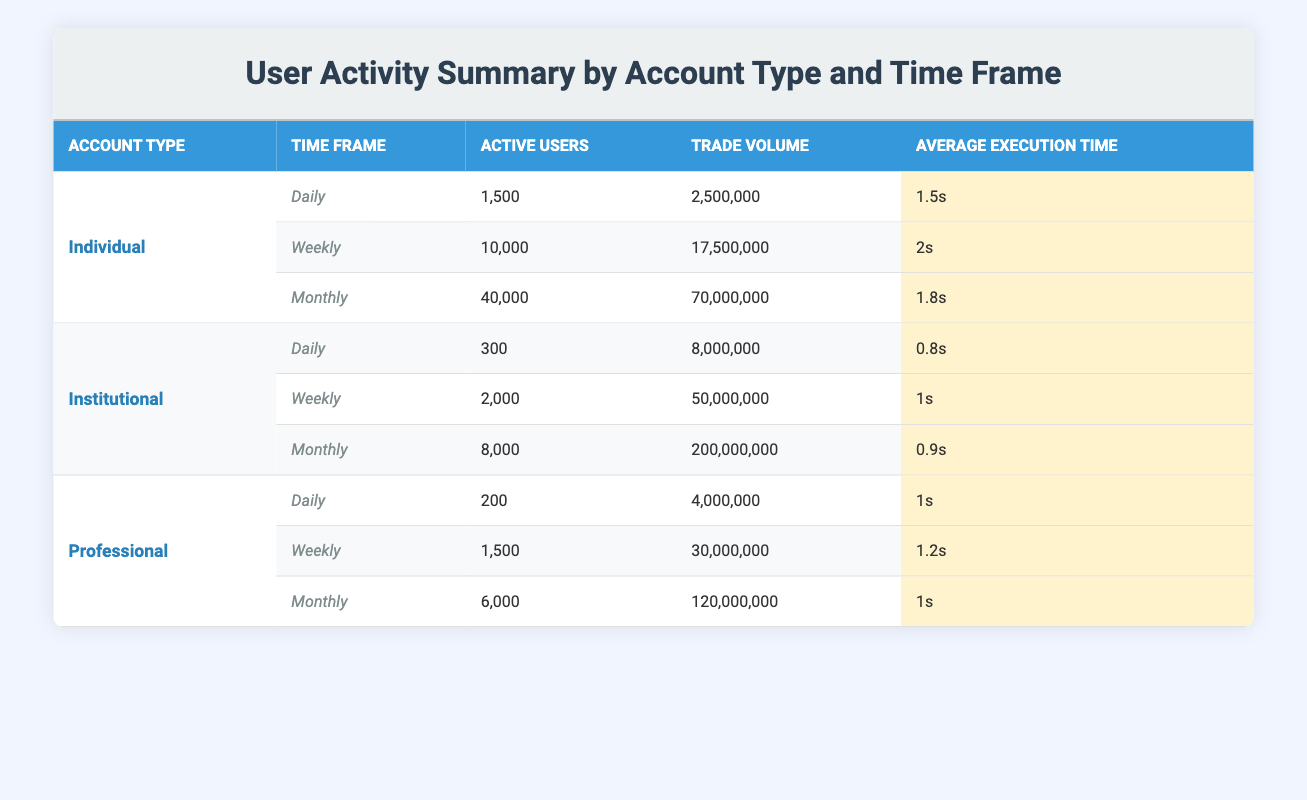What is the average execution time for Individual accounts on a daily basis? Referring to the Daily row under Individual, the Average Execution Time is displayed as 1.5s.
Answer: 1.5s How many Active Users are there for Institutional accounts during the Weekly time frame? Looking at the Weekly row for Institutional accounts, the number of Active Users is 2000.
Answer: 2000 What is the Trade Volume for Professional accounts on a Monthly basis? The Monthly row for Professional accounts shows the Trade Volume as 120,000,000.
Answer: 120,000,000 Is the Average Execution Time for Institutional accounts lower than that for Individual accounts on a Monthly basis? For Individual accounts, the Average Execution Time is 1.8s, and for Institutional accounts, it is 0.9s. Since 0.9s is less than 1.8s, the statement is true.
Answer: Yes What is the total Trade Volume for Individual and Professional accounts combined on a Monthly basis? The Monthly Trade Volume for Individual accounts is 70,000,000 and for Professional accounts is 120,000,000. Adding these gives 70,000,000 + 120,000,000 = 190,000,000.
Answer: 190,000,000 How many Active Users are there across all account types on a Daily basis? Daily Active Users for Individual accounts is 1,500, for Institutional accounts is 300, and for Professional accounts is 200. Summing these gives 1,500 + 300 + 200 = 2,000.
Answer: 2000 Is there an account type with an Average Execution Time higher than 2 seconds on a Weekly basis? The Average Execution Time for Individual accounts on a Weekly basis is 2s, and for other account types, it is less. None exceed 2 seconds. Therefore, the statement is false.
Answer: No What is the difference in Trade Volume between Weekly Institutional and Daily Individual accounts? The Weekly Trade Volume for Institutional accounts is 50,000,000 and the Daily Trade Volume for Individual accounts is 2,500,000. The difference is 50,000,000 - 2,500,000 = 47,500,000.
Answer: 47,500,000 Which account type has the highest number of Active Users on a Monthly basis? The Monthly Active Users are 40,000 for Individual, 8,000 for Institutional, and 6,000 for Professional accounts. Individual accounts have the highest at 40,000.
Answer: Individual 